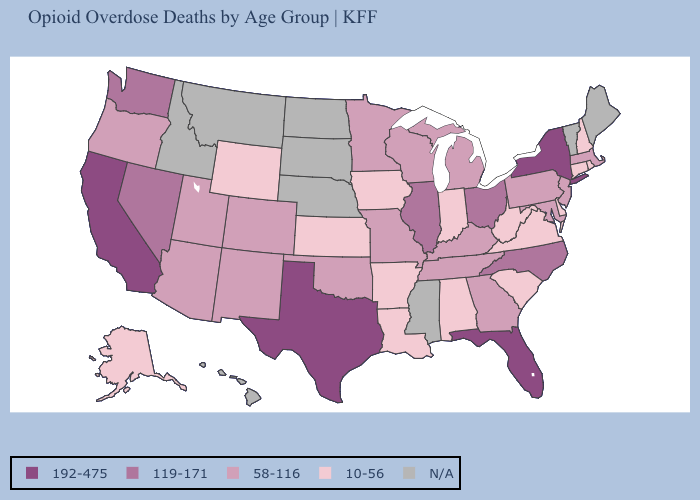Which states have the highest value in the USA?
Quick response, please. California, Florida, New York, Texas. Among the states that border California , does Oregon have the highest value?
Give a very brief answer. No. What is the value of South Dakota?
Be succinct. N/A. Name the states that have a value in the range N/A?
Short answer required. Hawaii, Idaho, Maine, Mississippi, Montana, Nebraska, North Dakota, South Dakota, Vermont. Does the first symbol in the legend represent the smallest category?
Concise answer only. No. Does Alaska have the lowest value in the West?
Keep it brief. Yes. Which states have the lowest value in the West?
Keep it brief. Alaska, Wyoming. Name the states that have a value in the range 10-56?
Quick response, please. Alabama, Alaska, Arkansas, Connecticut, Delaware, Indiana, Iowa, Kansas, Louisiana, New Hampshire, Rhode Island, South Carolina, Virginia, West Virginia, Wyoming. Name the states that have a value in the range 192-475?
Answer briefly. California, Florida, New York, Texas. Which states hav the highest value in the South?
Keep it brief. Florida, Texas. What is the value of Kansas?
Concise answer only. 10-56. Among the states that border New York , which have the lowest value?
Write a very short answer. Connecticut. Which states have the lowest value in the USA?
Short answer required. Alabama, Alaska, Arkansas, Connecticut, Delaware, Indiana, Iowa, Kansas, Louisiana, New Hampshire, Rhode Island, South Carolina, Virginia, West Virginia, Wyoming. Does Texas have the highest value in the USA?
Keep it brief. Yes. 